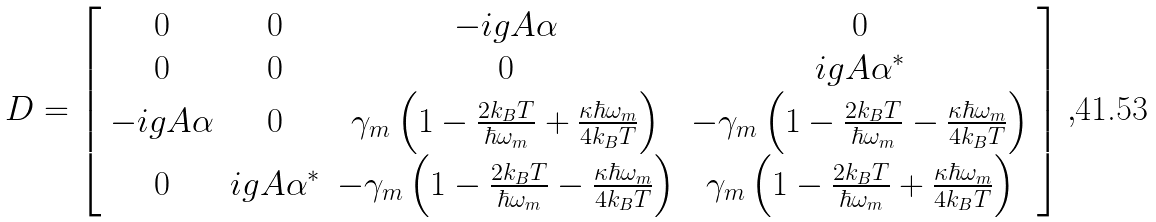Convert formula to latex. <formula><loc_0><loc_0><loc_500><loc_500>D = \left [ \begin{array} { c c c c } 0 & 0 & - i g A \alpha & 0 \\ 0 & 0 & 0 & i g A \alpha ^ { \ast } \\ - i g A \alpha & 0 & \gamma _ { m } \left ( 1 - \frac { 2 k _ { B } T } { \hbar { \omega } _ { m } } + \frac { \kappa \hbar { \omega } _ { m } } { 4 k _ { B } T } \right ) & - \gamma _ { m } \left ( 1 - \frac { 2 k _ { B } T } { \hbar { \omega } _ { m } } - \frac { \kappa \hbar { \omega } _ { m } } { 4 k _ { B } T } \right ) \\ 0 & i g A \alpha ^ { \ast } & - \gamma _ { m } \left ( 1 - \frac { 2 k _ { B } T } { \hbar { \omega } _ { m } } - \frac { \kappa \hbar { \omega } _ { m } } { 4 k _ { B } T } \right ) & \gamma _ { m } \left ( 1 - \frac { 2 k _ { B } T } { \hbar { \omega } _ { m } } + \frac { \kappa \hbar { \omega } _ { m } } { 4 k _ { B } T } \right ) \end{array} \right ] ,</formula> 